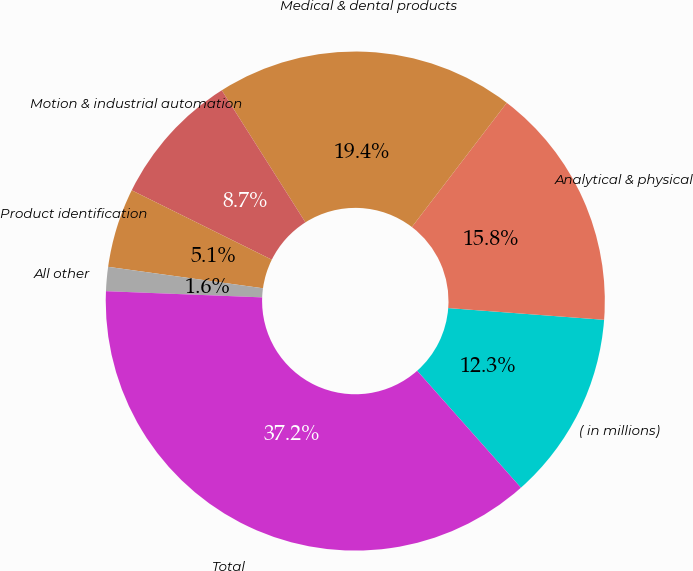Convert chart. <chart><loc_0><loc_0><loc_500><loc_500><pie_chart><fcel>( in millions)<fcel>Analytical & physical<fcel>Medical & dental products<fcel>Motion & industrial automation<fcel>Product identification<fcel>All other<fcel>Total<nl><fcel>12.25%<fcel>15.81%<fcel>19.37%<fcel>8.69%<fcel>5.13%<fcel>1.56%<fcel>37.18%<nl></chart> 